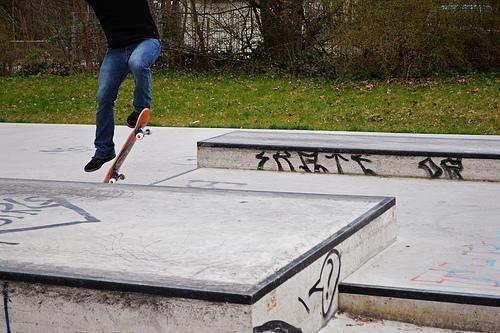How many people are in the picture?
Give a very brief answer. 1. 